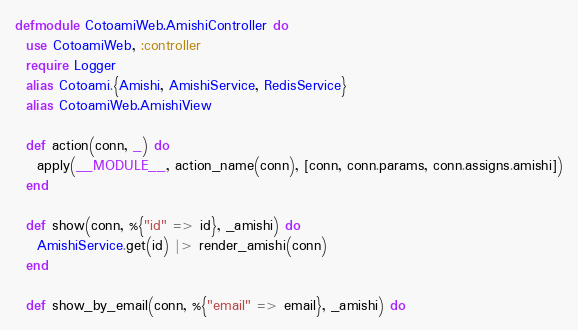<code> <loc_0><loc_0><loc_500><loc_500><_Elixir_>defmodule CotoamiWeb.AmishiController do
  use CotoamiWeb, :controller
  require Logger
  alias Cotoami.{Amishi, AmishiService, RedisService}
  alias CotoamiWeb.AmishiView

  def action(conn, _) do
    apply(__MODULE__, action_name(conn), [conn, conn.params, conn.assigns.amishi])
  end

  def show(conn, %{"id" => id}, _amishi) do
    AmishiService.get(id) |> render_amishi(conn)
  end

  def show_by_email(conn, %{"email" => email}, _amishi) do</code> 